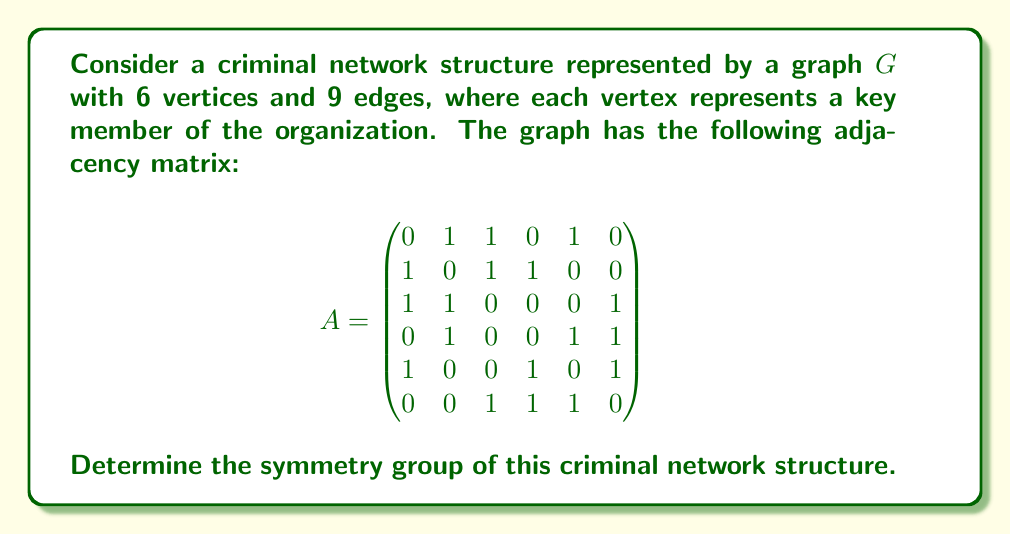Solve this math problem. To determine the symmetry group of the criminal network structure, we need to follow these steps:

1) First, we need to identify the automorphisms of the graph. An automorphism is a permutation of the vertices that preserves adjacency.

2) Looking at the adjacency matrix, we can see that:
   - Vertices 1, 2, 3, 5, and 6 all have degree 3
   - Vertex 4 has degree 3 as well, but its neighbors (2, 5, 6) form a different subgraph compared to the others

3) The only non-trivial automorphism possible is the swap of vertices 1 and 3. Let's verify:
   - Both are connected to 2
   - Both are connected to each other
   - 1 is connected to 5, 3 is connected to 6
   - Swapping 1 and 3 would also swap their connections to 5 and 6

4) We can represent this automorphism as the permutation (1 3)(5 6).

5) The symmetry group of the graph consists of two elements:
   - The identity permutation (1)(2)(3)(4)(5)(6)
   - The permutation (1 3)(5 6)

6) This group has order 2 and is isomorphic to the cyclic group $C_2$ or $\mathbb{Z}_2$.

Therefore, the symmetry group of this criminal network structure is $C_2$ or $\mathbb{Z}_2$.
Answer: $C_2$ or $\mathbb{Z}_2$ 